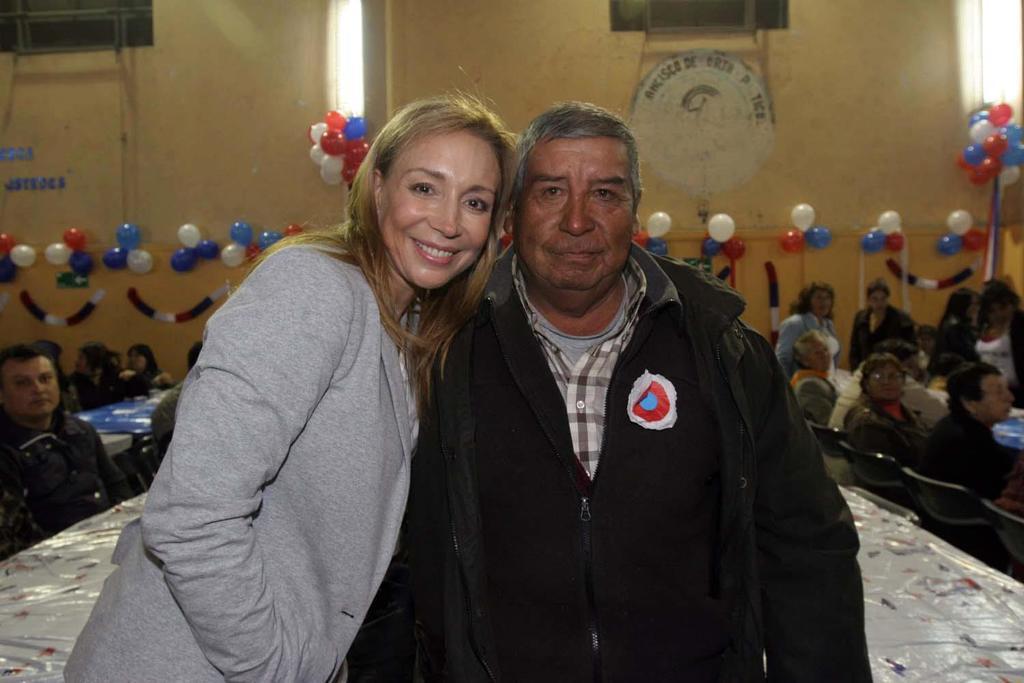In one or two sentences, can you explain what this image depicts? In the foreground of the picture I can see two persons. There is a man on the right side is wearing a black color coat. I can see a woman on the left side is wearing a jacket and there is a smile on their face. In the background, I can see a few persons sitting on the chairs and I can see the balloon decoration on the wall. 